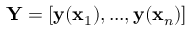Convert formula to latex. <formula><loc_0><loc_0><loc_500><loc_500>\mathbf Y = [ \mathbf y ( \mathbf x _ { 1 } ) , \dots , \mathbf y ( \mathbf x _ { n } ) ]</formula> 